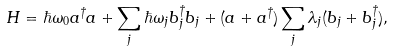<formula> <loc_0><loc_0><loc_500><loc_500>H = \hbar { \omega } _ { 0 } a ^ { \dagger } a + \sum _ { j } \hbar { \omega } _ { j } b _ { j } ^ { \dagger } b _ { j } + ( a + a ^ { \dagger } ) \sum _ { j } \lambda _ { j } ( b _ { j } + b _ { j } ^ { \dagger } ) ,</formula> 